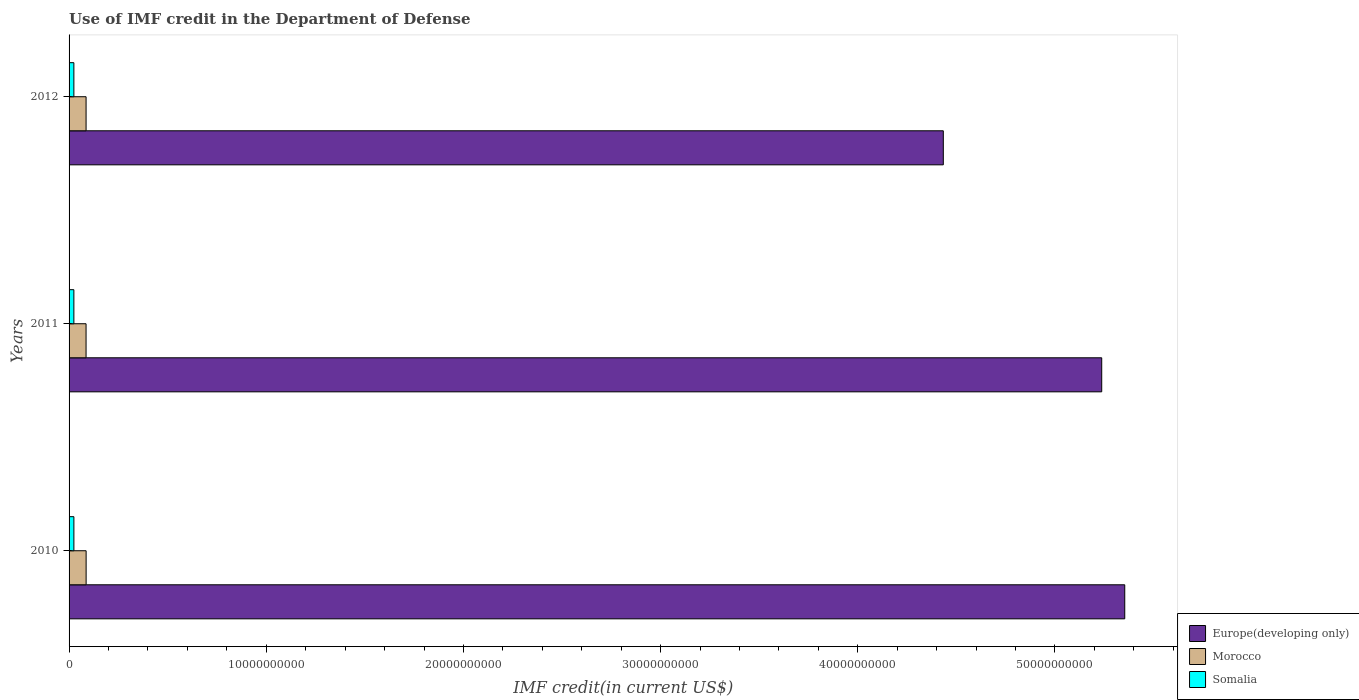How many groups of bars are there?
Offer a very short reply. 3. Are the number of bars on each tick of the Y-axis equal?
Your answer should be very brief. Yes. How many bars are there on the 1st tick from the top?
Ensure brevity in your answer.  3. In how many cases, is the number of bars for a given year not equal to the number of legend labels?
Give a very brief answer. 0. What is the IMF credit in the Department of Defense in Morocco in 2011?
Offer a terse response. 8.62e+08. Across all years, what is the maximum IMF credit in the Department of Defense in Europe(developing only)?
Offer a very short reply. 5.35e+1. Across all years, what is the minimum IMF credit in the Department of Defense in Europe(developing only)?
Your response must be concise. 4.43e+1. In which year was the IMF credit in the Department of Defense in Europe(developing only) minimum?
Make the answer very short. 2012. What is the total IMF credit in the Department of Defense in Europe(developing only) in the graph?
Your answer should be very brief. 1.50e+11. What is the difference between the IMF credit in the Department of Defense in Europe(developing only) in 2010 and that in 2012?
Provide a short and direct response. 9.20e+09. What is the difference between the IMF credit in the Department of Defense in Morocco in 2011 and the IMF credit in the Department of Defense in Somalia in 2012?
Your answer should be very brief. 6.19e+08. What is the average IMF credit in the Department of Defense in Morocco per year?
Offer a very short reply. 8.63e+08. In the year 2011, what is the difference between the IMF credit in the Department of Defense in Morocco and IMF credit in the Department of Defense in Europe(developing only)?
Your response must be concise. -5.15e+1. What is the ratio of the IMF credit in the Department of Defense in Morocco in 2010 to that in 2012?
Provide a succinct answer. 1. Is the IMF credit in the Department of Defense in Morocco in 2011 less than that in 2012?
Keep it short and to the point. Yes. Is the difference between the IMF credit in the Department of Defense in Morocco in 2010 and 2012 greater than the difference between the IMF credit in the Department of Defense in Europe(developing only) in 2010 and 2012?
Give a very brief answer. No. What is the difference between the highest and the second highest IMF credit in the Department of Defense in Morocco?
Your answer should be very brief. 1.75e+06. What is the difference between the highest and the lowest IMF credit in the Department of Defense in Europe(developing only)?
Your answer should be compact. 9.20e+09. In how many years, is the IMF credit in the Department of Defense in Somalia greater than the average IMF credit in the Department of Defense in Somalia taken over all years?
Make the answer very short. 1. What does the 3rd bar from the top in 2010 represents?
Keep it short and to the point. Europe(developing only). What does the 3rd bar from the bottom in 2012 represents?
Ensure brevity in your answer.  Somalia. Is it the case that in every year, the sum of the IMF credit in the Department of Defense in Somalia and IMF credit in the Department of Defense in Europe(developing only) is greater than the IMF credit in the Department of Defense in Morocco?
Your response must be concise. Yes. Are the values on the major ticks of X-axis written in scientific E-notation?
Offer a very short reply. No. Does the graph contain any zero values?
Give a very brief answer. No. How many legend labels are there?
Your answer should be compact. 3. What is the title of the graph?
Provide a succinct answer. Use of IMF credit in the Department of Defense. Does "New Caledonia" appear as one of the legend labels in the graph?
Offer a very short reply. No. What is the label or title of the X-axis?
Give a very brief answer. IMF credit(in current US$). What is the IMF credit(in current US$) of Europe(developing only) in 2010?
Provide a short and direct response. 5.35e+1. What is the IMF credit(in current US$) of Morocco in 2010?
Offer a terse response. 8.65e+08. What is the IMF credit(in current US$) in Somalia in 2010?
Provide a succinct answer. 2.44e+08. What is the IMF credit(in current US$) of Europe(developing only) in 2011?
Ensure brevity in your answer.  5.24e+1. What is the IMF credit(in current US$) of Morocco in 2011?
Your answer should be very brief. 8.62e+08. What is the IMF credit(in current US$) of Somalia in 2011?
Your answer should be very brief. 2.43e+08. What is the IMF credit(in current US$) in Europe(developing only) in 2012?
Your answer should be compact. 4.43e+1. What is the IMF credit(in current US$) in Morocco in 2012?
Your answer should be compact. 8.63e+08. What is the IMF credit(in current US$) of Somalia in 2012?
Make the answer very short. 2.43e+08. Across all years, what is the maximum IMF credit(in current US$) of Europe(developing only)?
Your response must be concise. 5.35e+1. Across all years, what is the maximum IMF credit(in current US$) in Morocco?
Make the answer very short. 8.65e+08. Across all years, what is the maximum IMF credit(in current US$) of Somalia?
Your answer should be very brief. 2.44e+08. Across all years, what is the minimum IMF credit(in current US$) in Europe(developing only)?
Provide a succinct answer. 4.43e+1. Across all years, what is the minimum IMF credit(in current US$) of Morocco?
Make the answer very short. 8.62e+08. Across all years, what is the minimum IMF credit(in current US$) in Somalia?
Your answer should be very brief. 2.43e+08. What is the total IMF credit(in current US$) of Europe(developing only) in the graph?
Your answer should be very brief. 1.50e+11. What is the total IMF credit(in current US$) of Morocco in the graph?
Ensure brevity in your answer.  2.59e+09. What is the total IMF credit(in current US$) in Somalia in the graph?
Your answer should be compact. 7.31e+08. What is the difference between the IMF credit(in current US$) of Europe(developing only) in 2010 and that in 2011?
Offer a terse response. 1.17e+09. What is the difference between the IMF credit(in current US$) in Morocco in 2010 and that in 2011?
Make the answer very short. 2.67e+06. What is the difference between the IMF credit(in current US$) of Somalia in 2010 and that in 2011?
Your response must be concise. 7.54e+05. What is the difference between the IMF credit(in current US$) in Europe(developing only) in 2010 and that in 2012?
Your response must be concise. 9.20e+09. What is the difference between the IMF credit(in current US$) in Morocco in 2010 and that in 2012?
Make the answer very short. 1.75e+06. What is the difference between the IMF credit(in current US$) in Somalia in 2010 and that in 2012?
Make the answer very short. 6.92e+05. What is the difference between the IMF credit(in current US$) of Europe(developing only) in 2011 and that in 2012?
Ensure brevity in your answer.  8.03e+09. What is the difference between the IMF credit(in current US$) of Morocco in 2011 and that in 2012?
Your answer should be very brief. -9.27e+05. What is the difference between the IMF credit(in current US$) of Somalia in 2011 and that in 2012?
Provide a short and direct response. -6.20e+04. What is the difference between the IMF credit(in current US$) in Europe(developing only) in 2010 and the IMF credit(in current US$) in Morocco in 2011?
Make the answer very short. 5.27e+1. What is the difference between the IMF credit(in current US$) of Europe(developing only) in 2010 and the IMF credit(in current US$) of Somalia in 2011?
Keep it short and to the point. 5.33e+1. What is the difference between the IMF credit(in current US$) of Morocco in 2010 and the IMF credit(in current US$) of Somalia in 2011?
Offer a very short reply. 6.21e+08. What is the difference between the IMF credit(in current US$) in Europe(developing only) in 2010 and the IMF credit(in current US$) in Morocco in 2012?
Your answer should be compact. 5.27e+1. What is the difference between the IMF credit(in current US$) in Europe(developing only) in 2010 and the IMF credit(in current US$) in Somalia in 2012?
Ensure brevity in your answer.  5.33e+1. What is the difference between the IMF credit(in current US$) of Morocco in 2010 and the IMF credit(in current US$) of Somalia in 2012?
Your answer should be very brief. 6.21e+08. What is the difference between the IMF credit(in current US$) of Europe(developing only) in 2011 and the IMF credit(in current US$) of Morocco in 2012?
Your answer should be compact. 5.15e+1. What is the difference between the IMF credit(in current US$) of Europe(developing only) in 2011 and the IMF credit(in current US$) of Somalia in 2012?
Keep it short and to the point. 5.21e+1. What is the difference between the IMF credit(in current US$) of Morocco in 2011 and the IMF credit(in current US$) of Somalia in 2012?
Your answer should be compact. 6.19e+08. What is the average IMF credit(in current US$) of Europe(developing only) per year?
Provide a short and direct response. 5.01e+1. What is the average IMF credit(in current US$) in Morocco per year?
Your answer should be very brief. 8.63e+08. What is the average IMF credit(in current US$) of Somalia per year?
Offer a terse response. 2.44e+08. In the year 2010, what is the difference between the IMF credit(in current US$) in Europe(developing only) and IMF credit(in current US$) in Morocco?
Offer a very short reply. 5.27e+1. In the year 2010, what is the difference between the IMF credit(in current US$) of Europe(developing only) and IMF credit(in current US$) of Somalia?
Your answer should be compact. 5.33e+1. In the year 2010, what is the difference between the IMF credit(in current US$) of Morocco and IMF credit(in current US$) of Somalia?
Your answer should be very brief. 6.21e+08. In the year 2011, what is the difference between the IMF credit(in current US$) in Europe(developing only) and IMF credit(in current US$) in Morocco?
Your answer should be compact. 5.15e+1. In the year 2011, what is the difference between the IMF credit(in current US$) in Europe(developing only) and IMF credit(in current US$) in Somalia?
Your answer should be very brief. 5.21e+1. In the year 2011, what is the difference between the IMF credit(in current US$) in Morocco and IMF credit(in current US$) in Somalia?
Give a very brief answer. 6.19e+08. In the year 2012, what is the difference between the IMF credit(in current US$) of Europe(developing only) and IMF credit(in current US$) of Morocco?
Your response must be concise. 4.35e+1. In the year 2012, what is the difference between the IMF credit(in current US$) of Europe(developing only) and IMF credit(in current US$) of Somalia?
Ensure brevity in your answer.  4.41e+1. In the year 2012, what is the difference between the IMF credit(in current US$) in Morocco and IMF credit(in current US$) in Somalia?
Provide a succinct answer. 6.20e+08. What is the ratio of the IMF credit(in current US$) of Europe(developing only) in 2010 to that in 2011?
Ensure brevity in your answer.  1.02. What is the ratio of the IMF credit(in current US$) of Europe(developing only) in 2010 to that in 2012?
Your answer should be compact. 1.21. What is the ratio of the IMF credit(in current US$) in Morocco in 2010 to that in 2012?
Provide a short and direct response. 1. What is the ratio of the IMF credit(in current US$) of Somalia in 2010 to that in 2012?
Your answer should be very brief. 1. What is the ratio of the IMF credit(in current US$) in Europe(developing only) in 2011 to that in 2012?
Keep it short and to the point. 1.18. What is the ratio of the IMF credit(in current US$) in Morocco in 2011 to that in 2012?
Your answer should be compact. 1. What is the difference between the highest and the second highest IMF credit(in current US$) of Europe(developing only)?
Offer a terse response. 1.17e+09. What is the difference between the highest and the second highest IMF credit(in current US$) of Morocco?
Provide a short and direct response. 1.75e+06. What is the difference between the highest and the second highest IMF credit(in current US$) in Somalia?
Keep it short and to the point. 6.92e+05. What is the difference between the highest and the lowest IMF credit(in current US$) in Europe(developing only)?
Your response must be concise. 9.20e+09. What is the difference between the highest and the lowest IMF credit(in current US$) in Morocco?
Offer a terse response. 2.67e+06. What is the difference between the highest and the lowest IMF credit(in current US$) of Somalia?
Ensure brevity in your answer.  7.54e+05. 